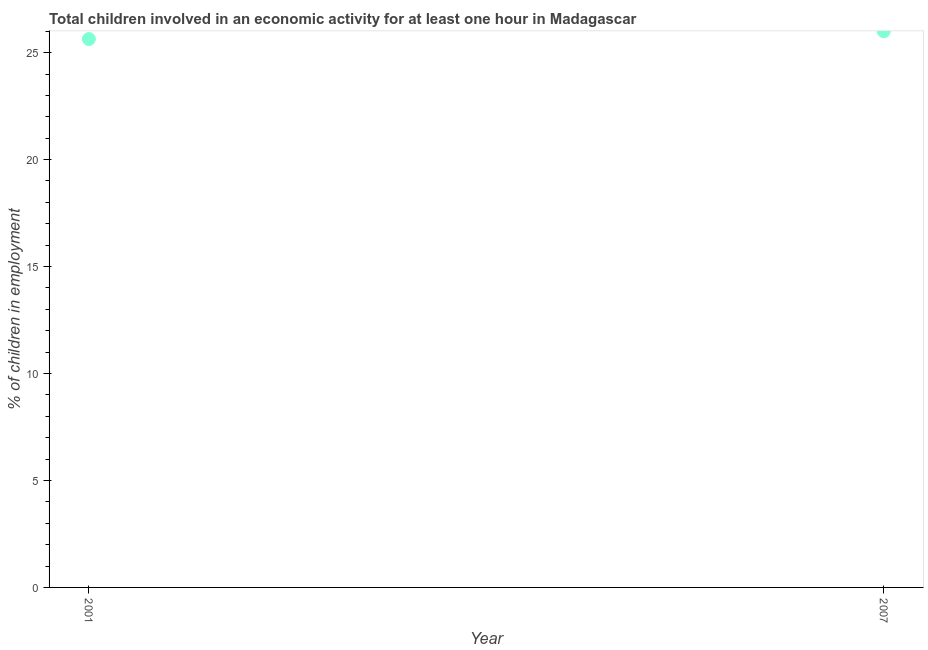What is the percentage of children in employment in 2007?
Offer a terse response. 26. Across all years, what is the maximum percentage of children in employment?
Keep it short and to the point. 26. Across all years, what is the minimum percentage of children in employment?
Make the answer very short. 25.63. In which year was the percentage of children in employment minimum?
Make the answer very short. 2001. What is the sum of the percentage of children in employment?
Your answer should be very brief. 51.63. What is the difference between the percentage of children in employment in 2001 and 2007?
Your answer should be very brief. -0.37. What is the average percentage of children in employment per year?
Provide a short and direct response. 25.82. What is the median percentage of children in employment?
Offer a very short reply. 25.82. Do a majority of the years between 2007 and 2001 (inclusive) have percentage of children in employment greater than 8 %?
Offer a terse response. No. What is the ratio of the percentage of children in employment in 2001 to that in 2007?
Give a very brief answer. 0.99. In how many years, is the percentage of children in employment greater than the average percentage of children in employment taken over all years?
Provide a short and direct response. 1. Does the percentage of children in employment monotonically increase over the years?
Offer a terse response. Yes. What is the difference between two consecutive major ticks on the Y-axis?
Provide a succinct answer. 5. Are the values on the major ticks of Y-axis written in scientific E-notation?
Ensure brevity in your answer.  No. Does the graph contain grids?
Offer a very short reply. No. What is the title of the graph?
Provide a short and direct response. Total children involved in an economic activity for at least one hour in Madagascar. What is the label or title of the X-axis?
Make the answer very short. Year. What is the label or title of the Y-axis?
Provide a succinct answer. % of children in employment. What is the % of children in employment in 2001?
Ensure brevity in your answer.  25.63. What is the difference between the % of children in employment in 2001 and 2007?
Ensure brevity in your answer.  -0.37. 